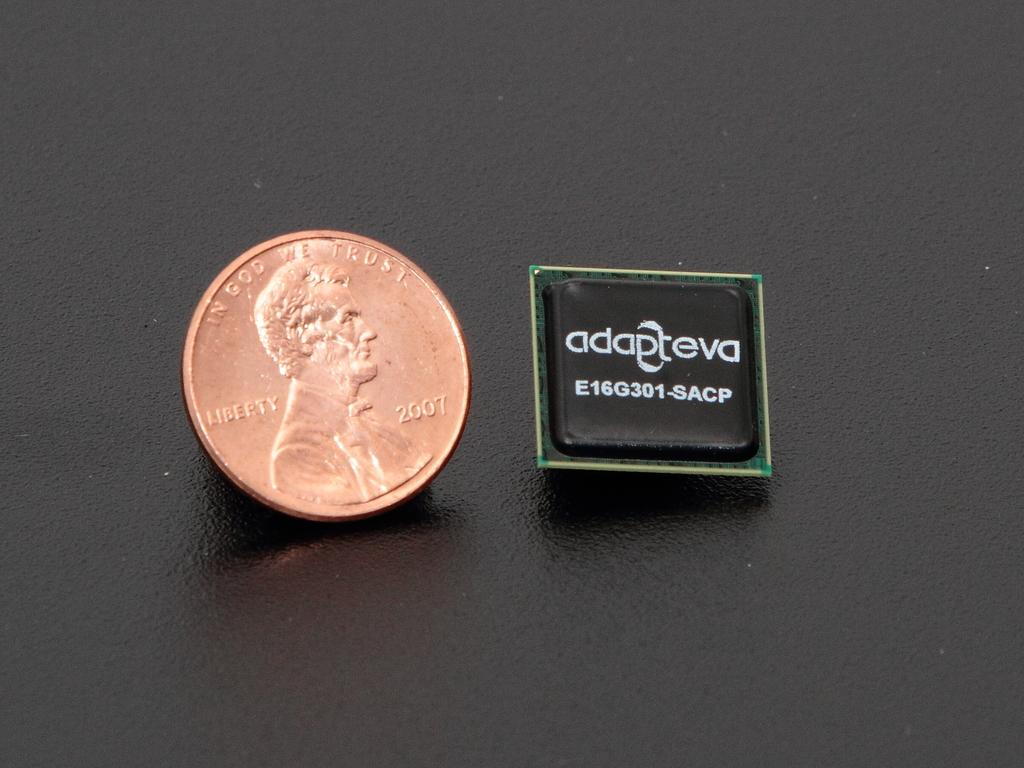What is located in the center of the image? There is a coin and a button in the center of the image. What is the color of the background in the image? The background of the image is black. How many rings are visible on the horse in the image? There is no horse present in the image, so there are no rings visible on a horse. What type of wound can be seen on the person in the image? There is no person present in the image, so there are no wounds visible. 